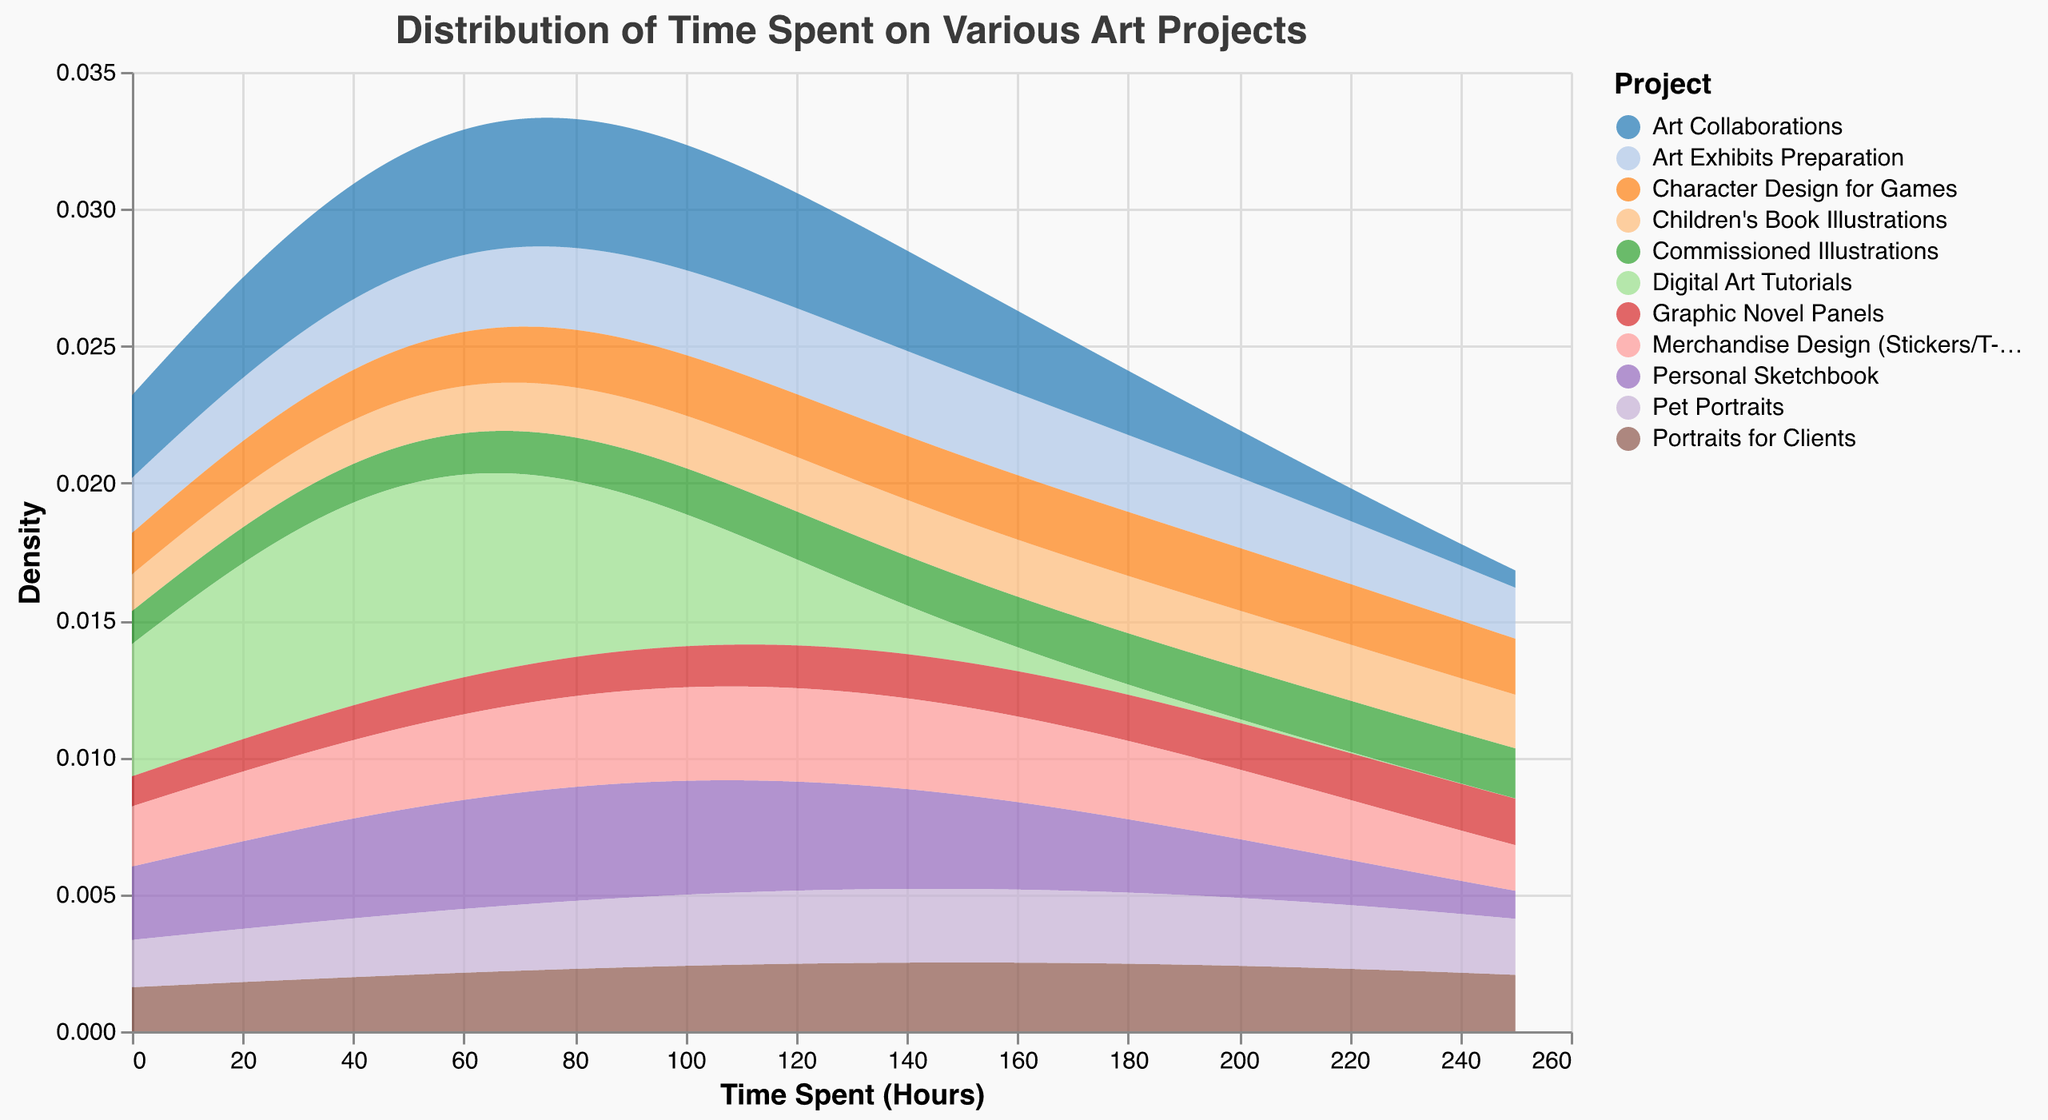What is the title of the plot? The title is usually displayed at the top of the chart and provides a summary of what the chart depicts. In this case, the title of the plot should be clear and visible at the top of the figure.
Answer: Distribution of Time Spent on Various Art Projects How many different art projects are represented in this plot? Each color in the plot represents a different art project. The legend typically lists the categories or groups that each color corresponds to. By counting the distinct colors or entries in the legend, you can determine the number of different art projects.
Answer: 11 Which art project has the highest density peak? By observing the plot, we can compare the density peaks of each art project. The one with the highest vertical peak represents the highest density.
Answer: Graphic Novel Panels What is the approximate median value of time spent on art projects? The median value can be estimated by looking at the value along the horizontal axis where the density is balanced on both sides. This is where half the data points lie below and half lie above. Since this is a visual estimate, it is approximate.
Answer: Around 140 hours Which art project has the least density near 100 hours? By examining the density curves near the 100-hour mark on the horizontal axis, we can identify which curve has the lowest density, indicating that the least amount of time was spent on that project near that value.
Answer: Digital Art Tutorials Is there overlapping in time distribution between "Children's Book Illustrations" and "Character Design for Games"? By comparing the density curves of these two projects, we can see if the curves overlap or intersect at any point along the horizontal axis. If they do, it indicates that there are time distributions where both projects share similar time spent.
Answer: Yes Which art projects have their highest density peaks between 50 and 150 hours? By focusing on the section of the plot between 50 and 150 hours, we can identify which density peaks fall within this range. Each curve peaking within this interval represents an art project with the highest density in that range.
Answer: Portraits for Clients and Personal Sketchbook What is the range of time spent on "Art Exhibits Preparation"? The range can be identified by noting where the density curve for "Art Exhibits Preparation" starts and ends along the horizontal axis. This tells us the span of values for time spent on this project.
Answer: 0 to 120 hours What's the difference in the peak density between "Commissioned Illustrations" and "Art Collaborations"? To find the difference, observe the highest density points for both projects and subtract the smaller density peak from the larger one.
Answer: Higher in Commissioned Illustrations How does the density of "Merchandise Design" compare to "Pet Portraits" at the 140-hour mark? By looking at the density values at the 140-hour point on the horizontal axis for both projects, we can compare the densities to see which one is higher or if they are roughly equal.
Answer: Lower in Merchandise Design 